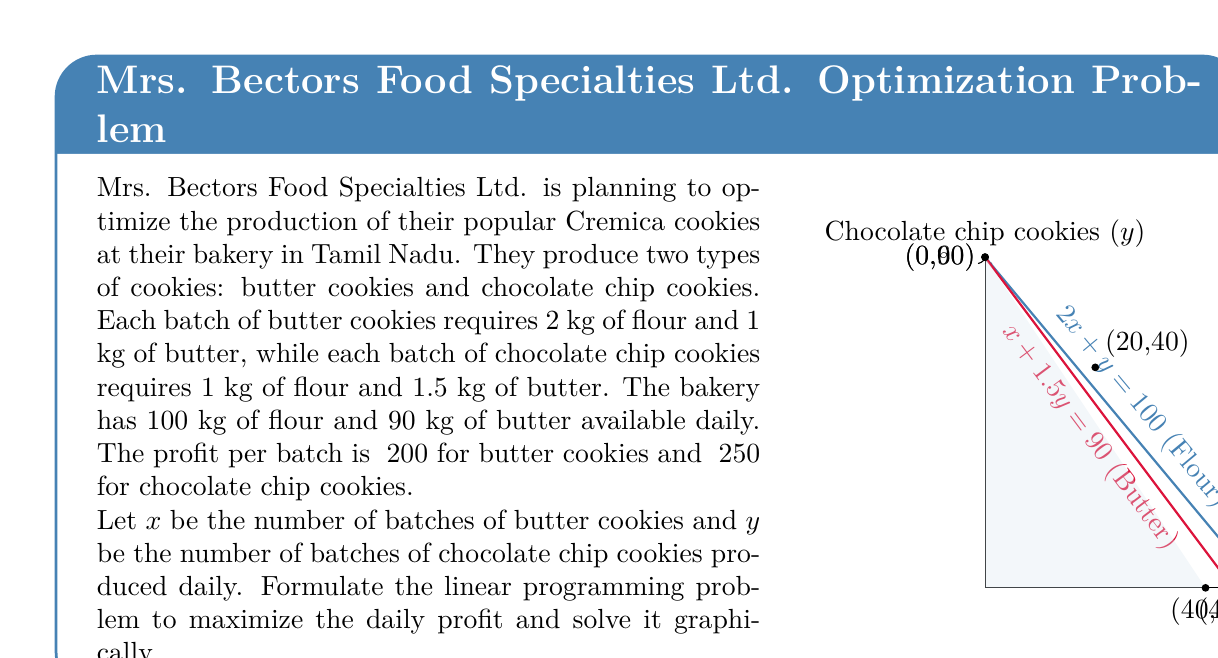Give your solution to this math problem. Let's solve this problem step by step:

1) First, we need to formulate the linear programming problem:

   Maximize: $Z = 200x + 250y$ (Profit function)
   Subject to:
   $2x + y \leq 100$ (Flour constraint)
   $x + 1.5y \leq 90$ (Butter constraint)
   $x \geq 0, y \geq 0$ (Non-negativity constraints)

2) Now, let's plot the constraints on a graph (as shown in the question).

3) The feasible region is the area bounded by these constraints and the axes.

4) The optimal solution will be at one of the corner points of this feasible region. The corner points are:
   (0,0), (40,0), (20,40), and (0,60)

5) Let's evaluate the profit function at each of these points:
   At (0,0): $Z = 200(0) + 250(0) = 0$
   At (40,0): $Z = 200(40) + 250(0) = 8000$
   At (20,40): $Z = 200(20) + 250(40) = 14000$
   At (0,60): $Z = 200(0) + 250(60) = 15000$

6) The maximum profit occurs at the point (0,60), which means producing 0 batches of butter cookies and 60 batches of chocolate chip cookies.

7) The maximum daily profit is ₹15000.
Answer: Produce 60 batches of chocolate chip cookies for a maximum daily profit of ₹15000. 